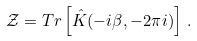<formula> <loc_0><loc_0><loc_500><loc_500>\mathcal { Z } = T r \left [ \hat { K } ( - i \beta , - 2 \pi i ) \right ] \, .</formula> 